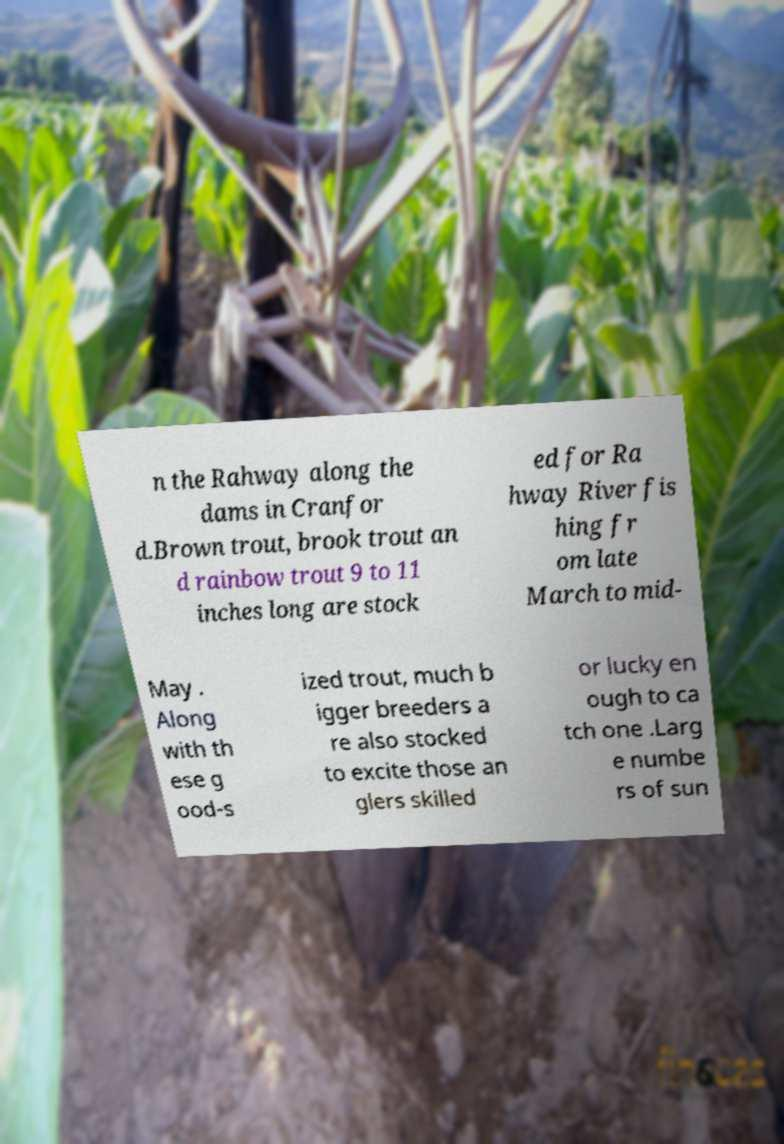Could you extract and type out the text from this image? n the Rahway along the dams in Cranfor d.Brown trout, brook trout an d rainbow trout 9 to 11 inches long are stock ed for Ra hway River fis hing fr om late March to mid- May . Along with th ese g ood-s ized trout, much b igger breeders a re also stocked to excite those an glers skilled or lucky en ough to ca tch one .Larg e numbe rs of sun 